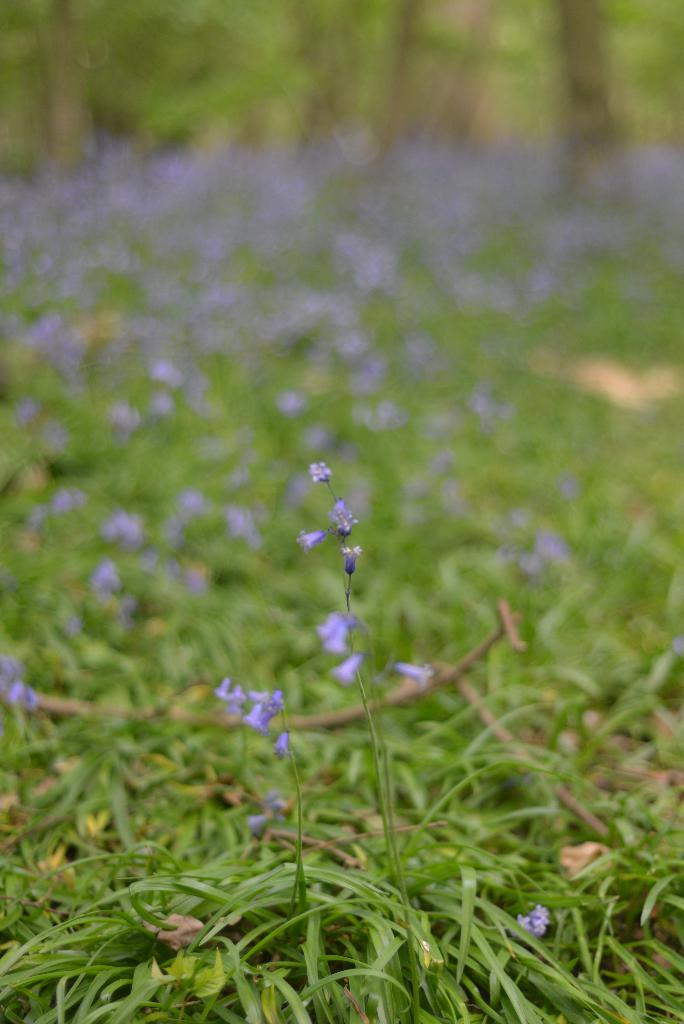What type of vegetation is present in the image? There is grass in the image. Are there any flowers visible in the image? Yes, there are violet color flowers in the image. How would you describe the clarity of the image? The image is blurry from the background. Where is the library located in the image? There is no library present in the image. What type of class is being held in the image? There is no class or educational setting depicted in the image. 